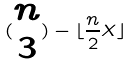Convert formula to latex. <formula><loc_0><loc_0><loc_500><loc_500>( \begin{matrix} n \\ 3 \end{matrix} ) - \lfloor \frac { n } { 2 } X \rfloor</formula> 